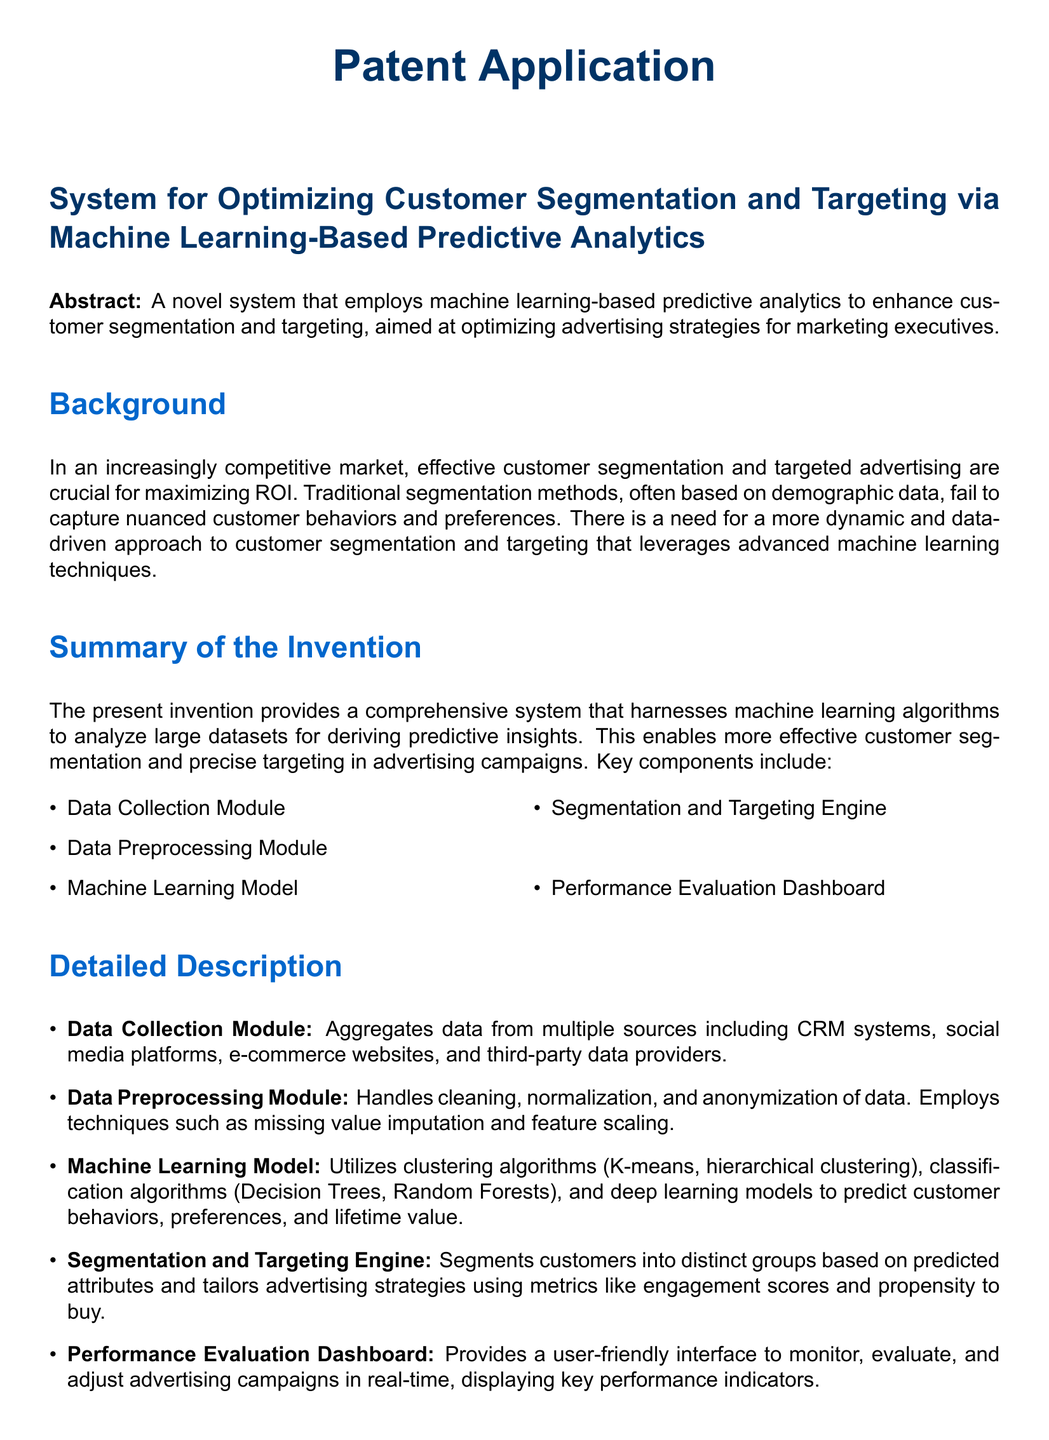What is the main goal of the invention? The main goal of the invention is to enhance customer segmentation and targeting, aimed at optimizing advertising strategies for marketing executives.
Answer: optimizing advertising strategies What are the key components of the system? The key components of the system include the Data Collection Module, Data Preprocessing Module, Machine Learning Model, Segmentation and Targeting Engine, and Performance Evaluation Dashboard.
Answer: Five components What does the Data Collection Module do? The Data Collection Module aggregates data from multiple sources including CRM systems, social media platforms, e-commerce websites, and third-party data providers.
Answer: Aggregates data Which machine learning algorithms are mentioned in the document? The document mentions clustering algorithms (K-means, hierarchical clustering) and classification algorithms (Decision Trees, Random Forests).
Answer: K-means, hierarchical clustering, Decision Trees, Random Forests What was the increase in conversion rates using the system? The retail company using the system saw a 20% increase in conversion rates.
Answer: 20% What performance metric is used for advertising strategies? The metric used for advertising strategies is engagement scores and propensity to buy.
Answer: engagement scores and propensity to buy What is the purpose of the Performance Evaluation Dashboard? The purpose of the Performance Evaluation Dashboard is to provide a user-friendly interface to monitor, evaluate, and adjust advertising campaigns in real-time.
Answer: monitor advertising campaigns What does the term "dynamic segmentation" refer to in this context? Dynamic segmentation refers to the process of segmenting customers into actionable groups for targeted advertising based on predictive insights.
Answer: segmenting customers What is claimed about real-time performance monitoring? The claim is that there is real-time performance monitoring through an integrated dashboard.
Answer: real-time performance monitoring What sector does the example application pertain to? The example application pertains to the retail sector.
Answer: retail sector 